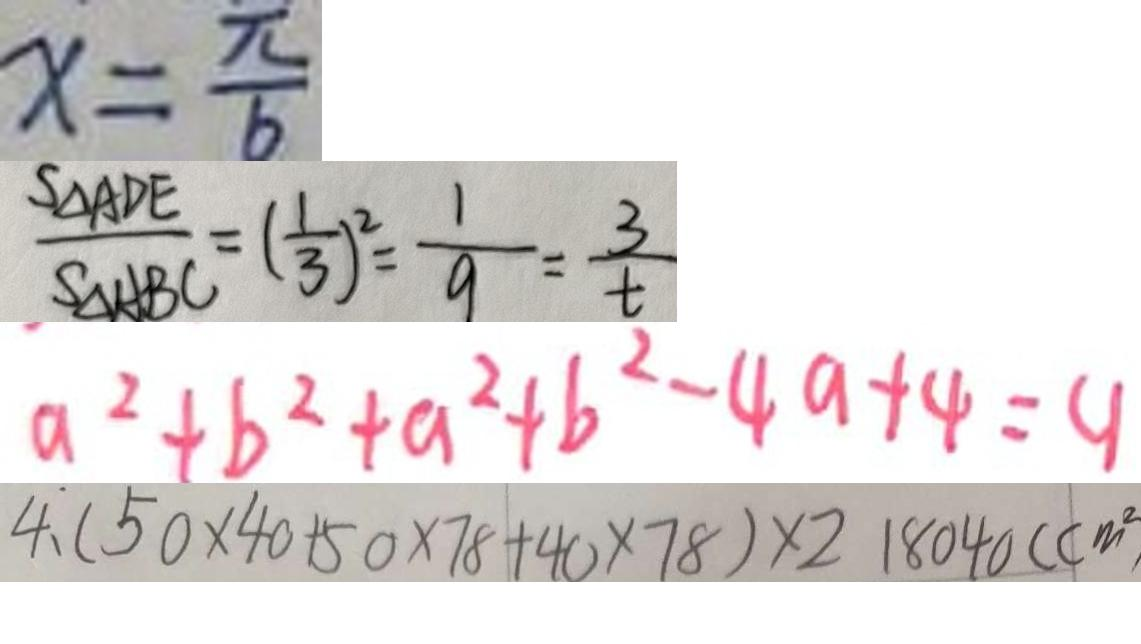Convert formula to latex. <formula><loc_0><loc_0><loc_500><loc_500>x = \frac { \pi } { b } 
 \frac { S _ { \Delta A D E } } { S _ { \Delta A B C } } = ( \frac { 1 } { 3 } ) ^ { 2 } = \frac { 1 } { 9 } = \frac { 3 } { t } 
 a ^ { 2 } + b ^ { 2 } + a ^ { 2 } + b ^ { 2 } - 4 a + 4 = 9 
 4 . ( 5 0 \times 4 0 + 5 0 \times 7 8 + 4 0 \times 7 8 ) \times 2 1 8 0 4 0 ( c m ^ { 2 }</formula> 